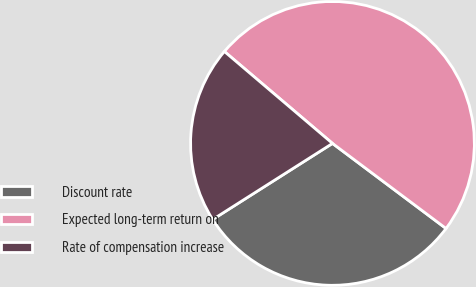Convert chart to OTSL. <chart><loc_0><loc_0><loc_500><loc_500><pie_chart><fcel>Discount rate<fcel>Expected long-term return on<fcel>Rate of compensation increase<nl><fcel>30.76%<fcel>49.02%<fcel>20.22%<nl></chart> 